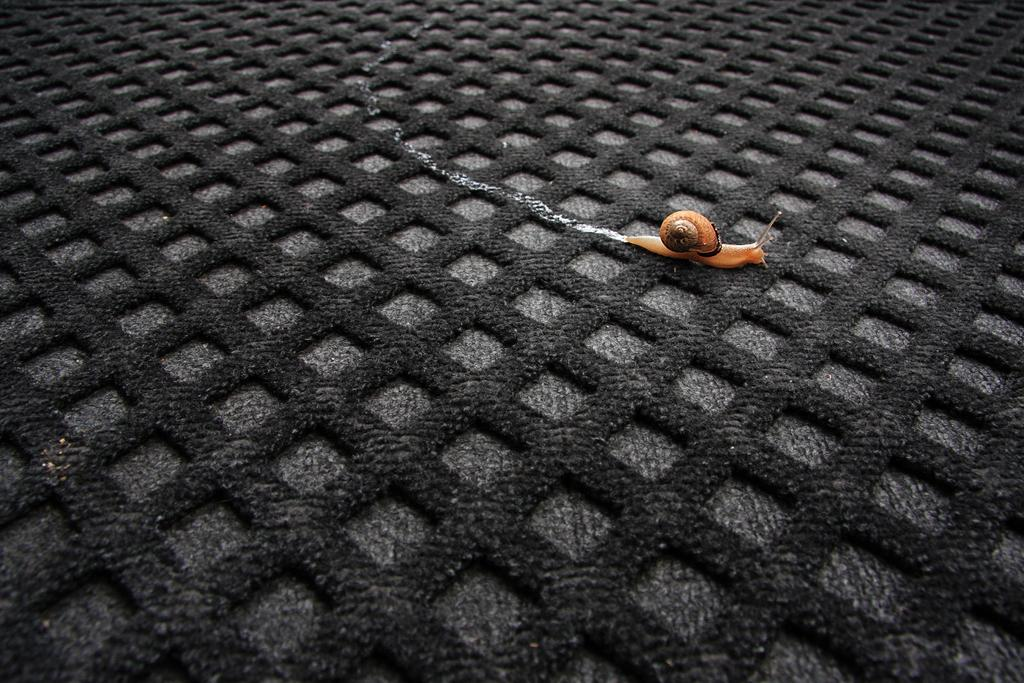What type of animal is in the image? There is a small snail in the image. Where is the snail located? The snail is on the ground. What else can be seen on the ground in the image? There are blocks of mat on the ground. What type of spoon is the queen holding in the image? There is no queen or spoon present in the image; it features a small snail on the ground and blocks of mat. 